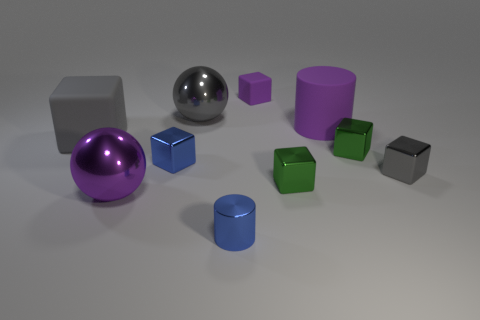Are there fewer gray shiny cubes that are on the right side of the tiny gray thing than tiny things?
Give a very brief answer. Yes. Is there a purple ball?
Keep it short and to the point. Yes. There is a small rubber object that is the same shape as the tiny gray metal object; what is its color?
Make the answer very short. Purple. Does the cylinder that is behind the large rubber block have the same color as the small rubber block?
Make the answer very short. Yes. Do the gray metallic ball and the purple cylinder have the same size?
Keep it short and to the point. Yes. What is the shape of the small purple object that is the same material as the purple cylinder?
Make the answer very short. Cube. How many other things are there of the same shape as the tiny purple rubber thing?
Provide a succinct answer. 5. What is the shape of the tiny green thing to the left of the large purple thing behind the matte object that is to the left of the purple rubber cube?
Your answer should be very brief. Cube. What number of spheres are either green objects or large rubber things?
Offer a very short reply. 0. Is there a big gray metal sphere right of the large purple object to the left of the big gray metallic object?
Provide a succinct answer. Yes. 